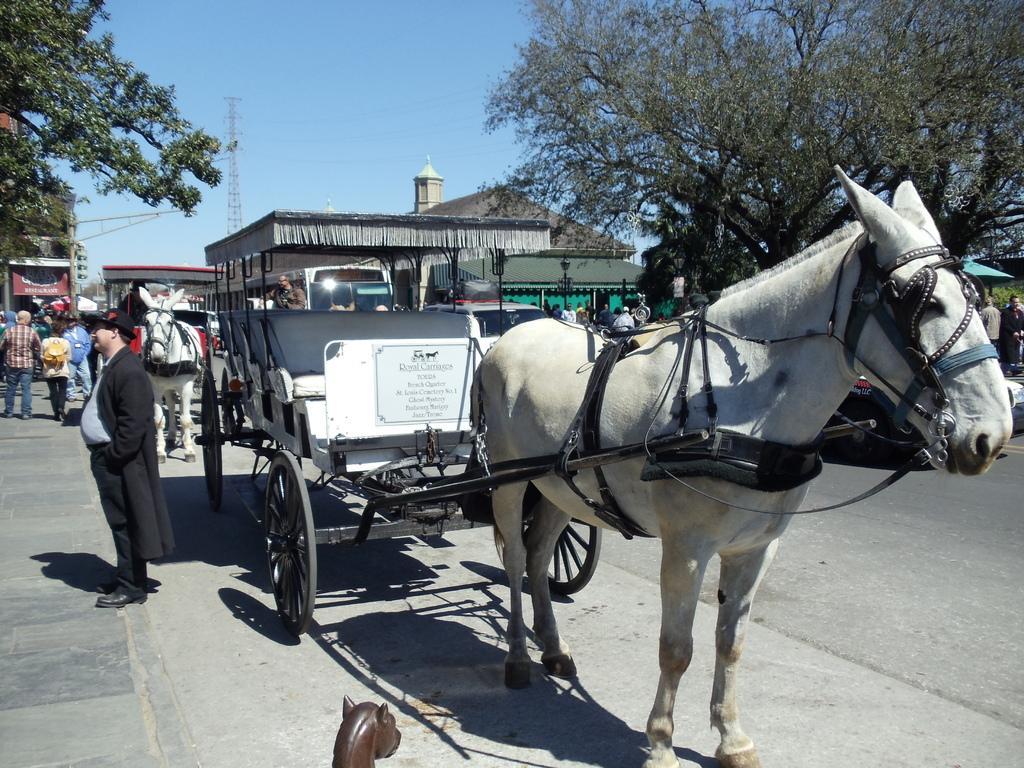Please provide a concise description of this image. In this image, we can see horse carts. There is a tree in the top right of the image. There is a branch in the top left of the image. There are persons on the left side of the image wearing clothes. There is a shelter in the middle of the image. There is a tower and sky at the top of the image. 